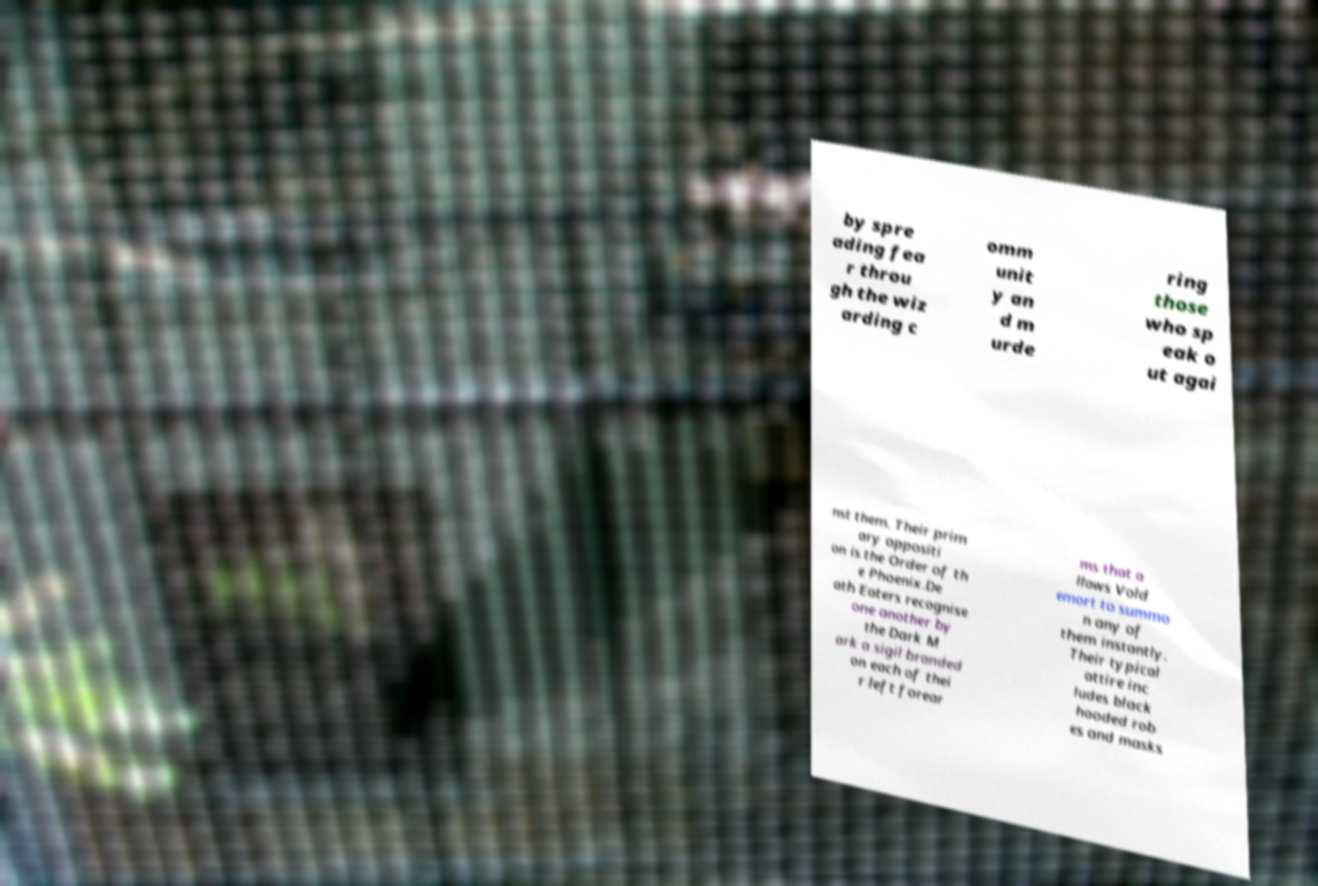For documentation purposes, I need the text within this image transcribed. Could you provide that? by spre ading fea r throu gh the wiz arding c omm unit y an d m urde ring those who sp eak o ut agai nst them. Their prim ary oppositi on is the Order of th e Phoenix.De ath Eaters recognise one another by the Dark M ark a sigil branded on each of thei r left forear ms that a llows Vold emort to summo n any of them instantly. Their typical attire inc ludes black hooded rob es and masks 